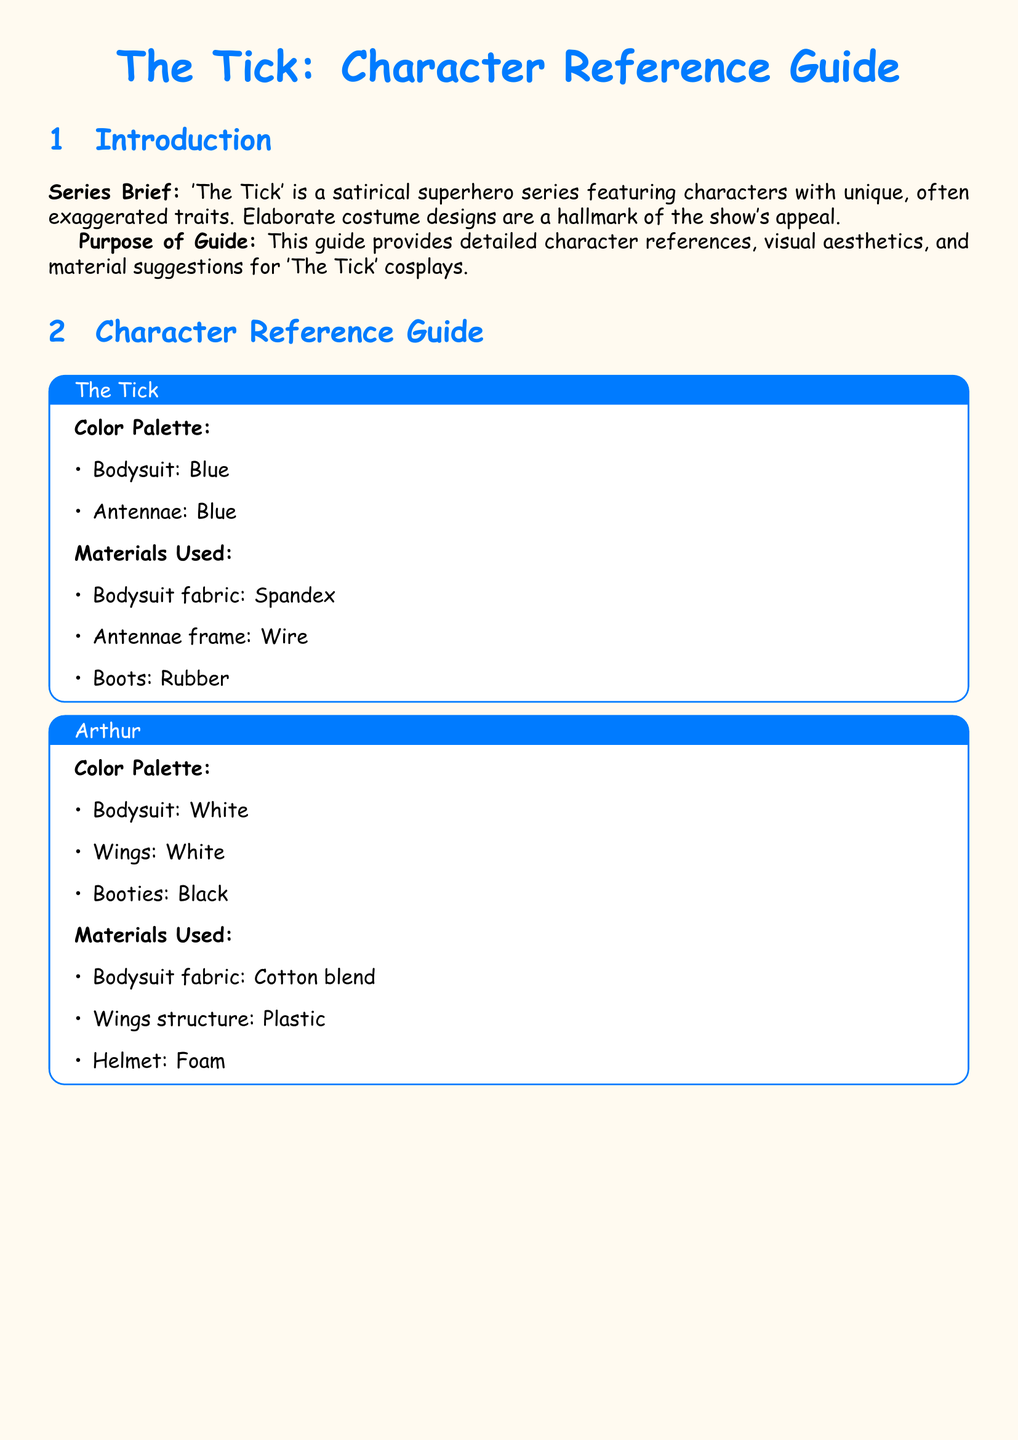What is the color of The Tick's bodysuit? The bodysuit color for The Tick is specified in the document as blue.
Answer: blue What material is used for Arthur’s helmet? The document lists the material used for Arthur’s helmet as foam.
Answer: foam What color are Dot's accessories? Dot's accessories are described as black in the character reference guide.
Answer: black What fabric is used for The Tick's bodysuit? The fabric for The Tick's bodysuit is stated to be spandex in the document.
Answer: spandex What is the primary color of Overkill's armor? The document specifies that Overkill's armor is black.
Answer: black How many characters are detailed in the guide? The document provides character references for four characters.
Answer: four What is the structure material of Arthur's wings? Arthur's wings structure is identified as plastic in the document.
Answer: plastic Which character is associated with a red cape? Overkill is the character associated with a red cape according to the document.
Answer: Overkill What color is Dot's jumpsuit? The jumpsuit color for Dot is specified as blue in the character reference guide.
Answer: blue 